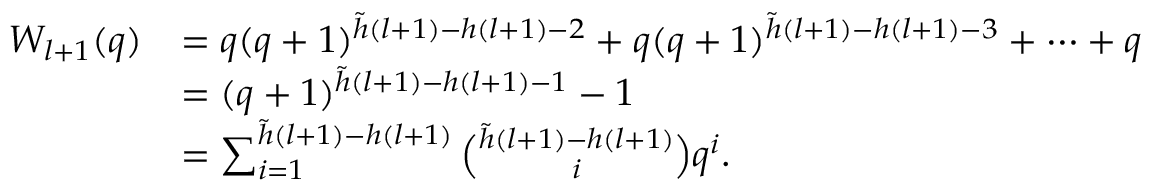<formula> <loc_0><loc_0><loc_500><loc_500>\begin{array} { r l } { W _ { l + 1 } ( q ) } & { = q ( q + 1 ) ^ { \tilde { h } ( l + 1 ) - h ( l + 1 ) - 2 } + q ( q + 1 ) ^ { \tilde { h } ( l + 1 ) - h ( l + 1 ) - 3 } + \cdots + q } \\ & { = ( q + 1 ) ^ { \tilde { h } ( l + 1 ) - h ( l + 1 ) - 1 } - 1 } \\ & { = \sum _ { i = 1 } ^ { \tilde { h } ( l + 1 ) - h ( l + 1 ) } { \binom { \tilde { h } ( l + 1 ) - h ( l + 1 ) } { i } } q ^ { i } . } \end{array}</formula> 